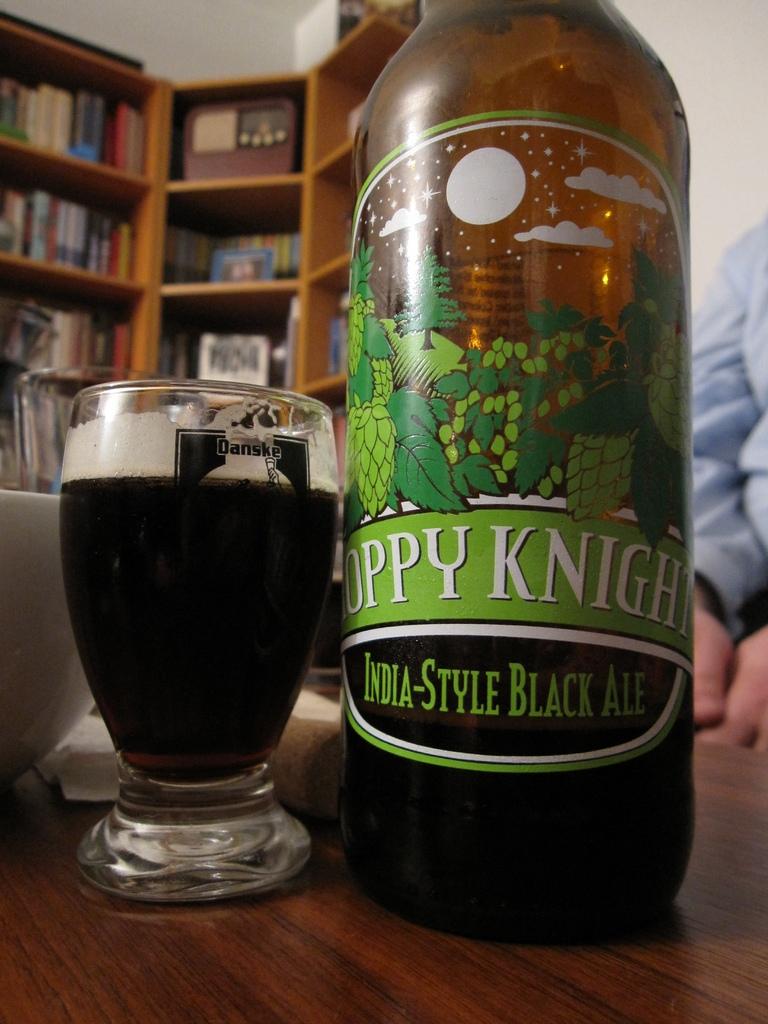What is the brand?
Your response must be concise. Hoppy knight. 